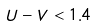Convert formula to latex. <formula><loc_0><loc_0><loc_500><loc_500>U - V < 1 . 4</formula> 